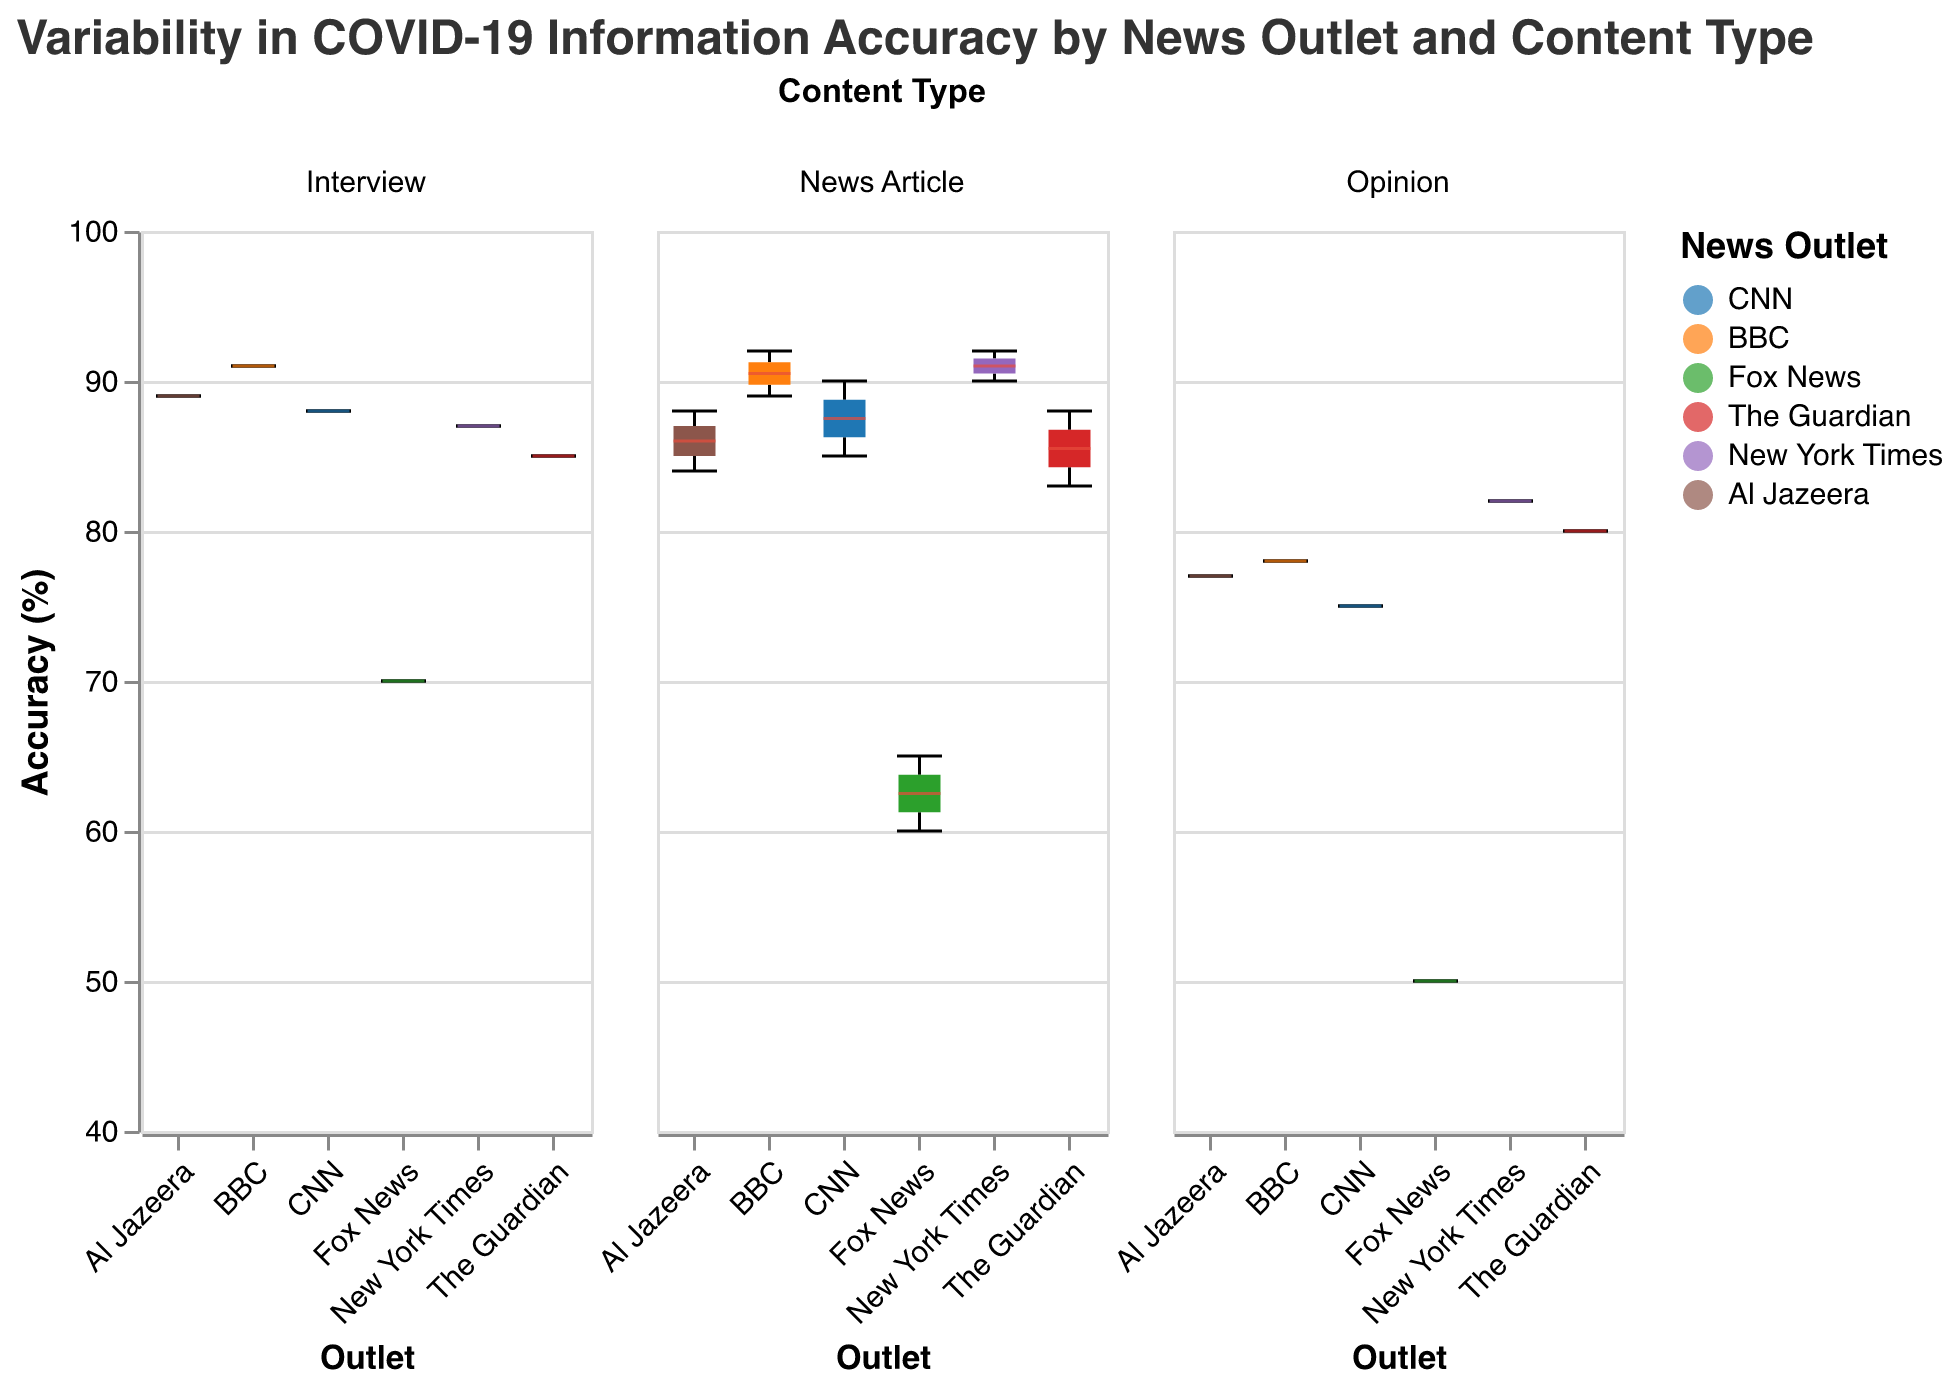What is the title of the figure? The title is located at the top of the figure, and it typically provides a brief description of what the figure represents. Here, we see that it reads "Variability in COVID-19 Information Accuracy by News Outlet and Content Type".
Answer: Variability in COVID-19 Information Accuracy by News Outlet and Content Type Which news outlet has the highest median accuracy for News Articles? To determine this, look at the median line for each box plot within the "News Article" column. The news outlet with the highest median line will be the one with the highest median accuracy. For News Articles, BBC appears to have the highest median accuracy.
Answer: BBC What is the range of accuracy for Fox News's Opinions? The range of accuracy can be identified by locating the min and max whiskers of the box plot for Fox News in the "Opinion" column. The minimum value is 50, and the maximum is 50, showing no variability in this case.
Answer: 50 to 50 Compare the median accuracy of Interviews between CNN and Al Jazeera. Which one is higher? To compare the median accuracy, look at the line dividing the boxes for "Interview" under both outlets. CNN's median is 88, while Al Jazeera's median is 89, making Al Jazeera's higher.
Answer: Al Jazeera How does the median of News Articles for Fox News compare to the median of Opinions for The Guardian? The median for Fox News's News Articles and The Guardian's Opinions can be identified by the respective box plot medians. Fox News's News Articles median is 62.5, and The Guardian's Opinions median is 80. By comparing the two, The Guardian's median for Opinions is higher.
Answer: The Guardian is higher Which news outlet shows the most variability in accuracy for News Articles? Variability within a box plot can be observed through the length of the box and the whiskers. For "News Article" type, Fox News shows the most variability with its larger interquartile range (IQR) and extended whiskers.
Answer: Fox News Are there any outliers in the accuracy data for CNN's Opinion pieces? Outliers would be represented by individual points that fall outside the whiskers of the box plot for CNN's Opinions. Here, there are no such points, indicating there are no outliers.
Answer: No What is the overall trend in accuracy for Opinion pieces across all news outlets? To identify this trend, analyze all the median lines for "Opinion" to ascertain if there is an upward, downward, or neutral trend. Most medians are considerably lower than for other types, indicating a trend of lower accuracy in Opinion pieces across all news outlets.
Answer: Generally lower accuracy Which type of content shows the highest overall accuracy across all outlets? To determine this, examine the medians of all box plots in each content type column (News Articles, Interviews, and Opinions). News Articles generally have higher medians compared to other types, indicating the highest overall accuracy.
Answer: News Articles Is there a significant difference in the median accuracy of Interviews between BBC and New York Times? Locate the median lines for "Interview" for both BBC and New York Times. BBC's median accuracy is 91, and New York Times' median is 87, making the difference 4 percentage points. While it might be significant, depending on the context (e.g., statistical significance), visually this can be seen as a moderate difference.
Answer: Yes, BBC is higher by 4 points 